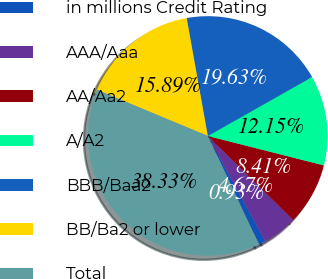Convert chart. <chart><loc_0><loc_0><loc_500><loc_500><pie_chart><fcel>in millions Credit Rating<fcel>AAA/Aaa<fcel>AA/Aa2<fcel>A/A2<fcel>BBB/Baa2<fcel>BB/Ba2 or lower<fcel>Total<nl><fcel>0.93%<fcel>4.67%<fcel>8.41%<fcel>12.15%<fcel>19.63%<fcel>15.89%<fcel>38.33%<nl></chart> 